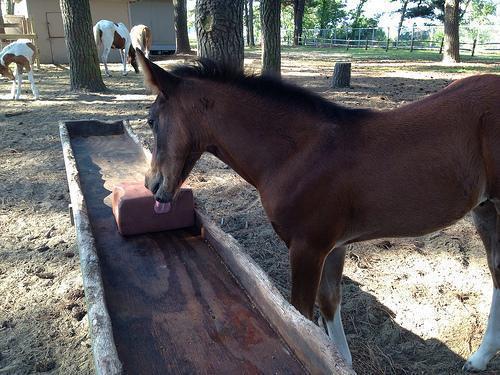How many horses are there?
Give a very brief answer. 4. 